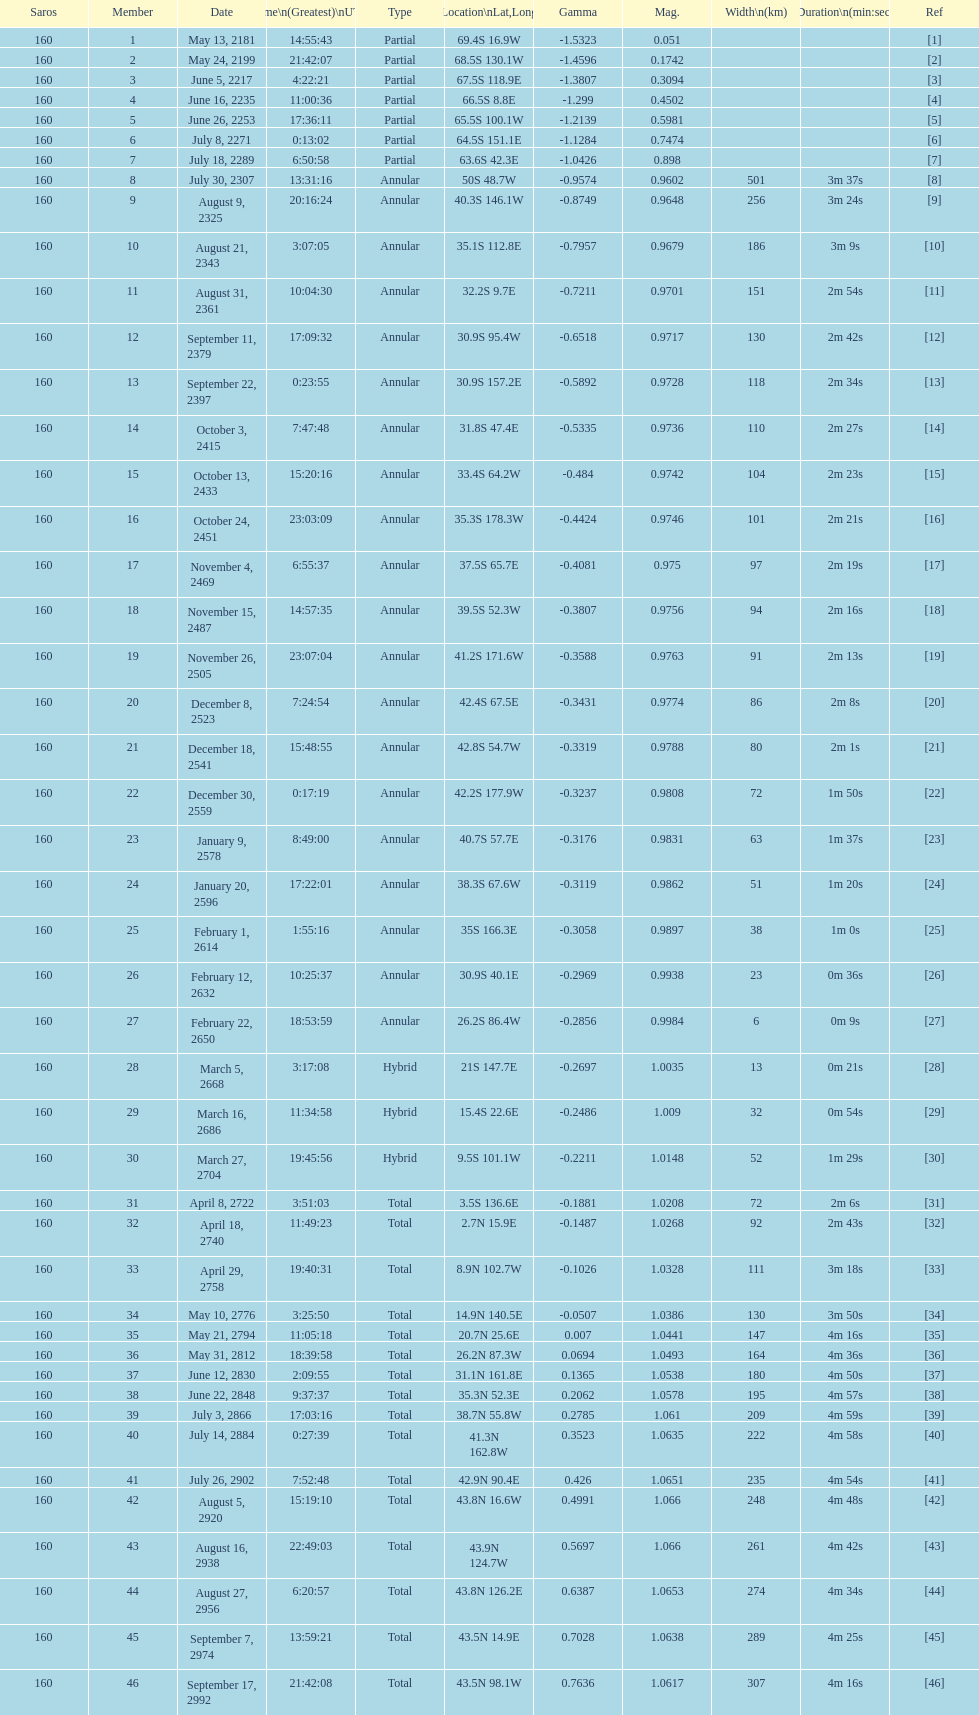How many partial members will occur before the first annular? 7. 